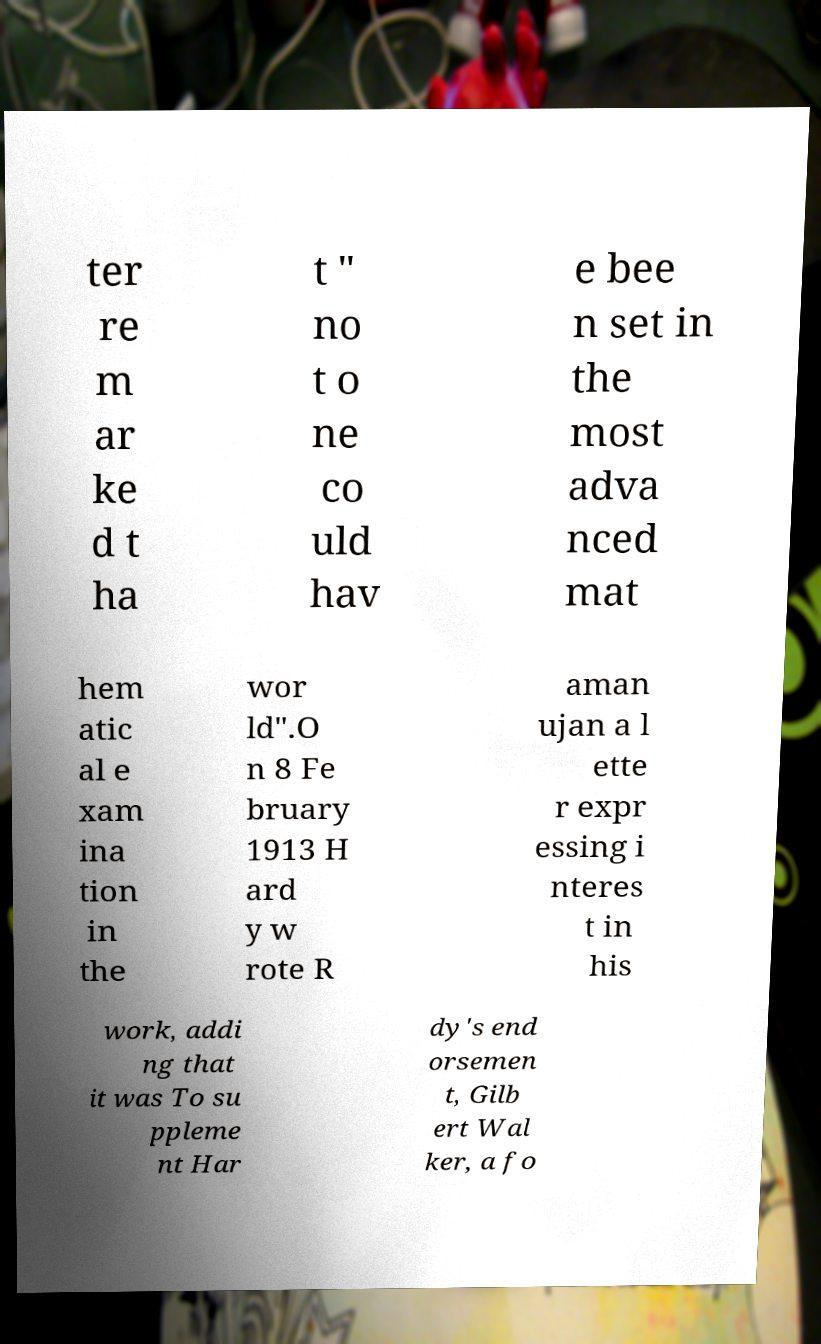Please read and relay the text visible in this image. What does it say? ter re m ar ke d t ha t " no t o ne co uld hav e bee n set in the most adva nced mat hem atic al e xam ina tion in the wor ld".O n 8 Fe bruary 1913 H ard y w rote R aman ujan a l ette r expr essing i nteres t in his work, addi ng that it was To su ppleme nt Har dy's end orsemen t, Gilb ert Wal ker, a fo 